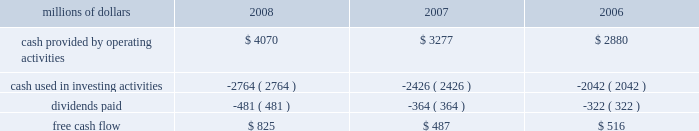Levels during 2008 , an indication that efforts to improve network operations translated into better customer service .
2022 fuel prices 2013 crude oil prices increased at a steady rate through the first seven months of 2008 , closing at a record high of $ 145.29 a barrel in early july .
As the economy worsened during the third and fourth quarters , fuel prices dropped dramatically , hitting $ 33.87 per barrel in december , a near five-year low .
Despite these price declines toward the end of the year , our 2008 average fuel price increased by 39% ( 39 % ) and added $ 1.1 billion of operating expenses compared to 2007 .
Our fuel surcharge programs helped offset the impact of higher fuel prices .
In addition , we reduced our consumption rate by 4% ( 4 % ) , saving approximately 58 million gallons of fuel during the year .
The use of newer , more fuel efficient locomotives ; our fuel conservation programs ; improved network operations ; and a shift in commodity mix , primarily due to growth in bulk shipments , contributed to the improvement .
2022 free cash flow 2013 cash generated by operating activities totaled a record $ 4.1 billion , yielding free cash flow of $ 825 million in 2008 .
Free cash flow is defined as cash provided by operating activities , less cash used in investing activities and dividends paid .
Free cash flow is not considered a financial measure under accounting principles generally accepted in the united states ( gaap ) by sec regulation g and item 10 of sec regulation s-k .
We believe free cash flow is important in evaluating our financial performance and measures our ability to generate cash without additional external financings .
Free cash flow should be considered in addition to , rather than as a substitute for , cash provided by operating activities .
The table reconciles cash provided by operating activities ( gaap measure ) to free cash flow ( non-gaap measure ) : millions of dollars 2008 2007 2006 .
2009 outlook 2022 safety 2013 operating a safe railroad benefits our employees , our customers , our shareholders , and the public .
We will continue using a multi-faceted approach to safety , utilizing technology , risk assessment , quality control , and training and engaging our employees .
We plan to continue implementation of total safety culture ( tsc ) throughout our operations .
Tsc , an employee-focused initiative that has helped improve safety , is a process designed to establish , maintain , and promote safety among co-workers .
With respect to public safety , we will continue our efforts to maintain , upgrade , and close crossings , install video cameras on locomotives , and educate the public about crossing safety through various railroad and industry programs , along with other activities .
2022 transportation plan 2013 in 2009 , we will continue to evaluate traffic flows and network logistic patterns to identify additional opportunities to simplify operations and improve network efficiency and asset utilization .
We plan to maintain adequate manpower and locomotives , and improve productivity using industrial engineering techniques .
2022 fuel prices 2013 on average , we expect fuel prices to decrease substantially from the average price we paid in 2008 .
However , due to economic uncertainty , other global pressures , and weather incidents , fuel prices again could be volatile during the year .
To reduce the impact of fuel price on earnings , we .
What was the operating expenses in 2007 in billions? 
Computations: (1.1 / 39%)
Answer: 2.82051. 